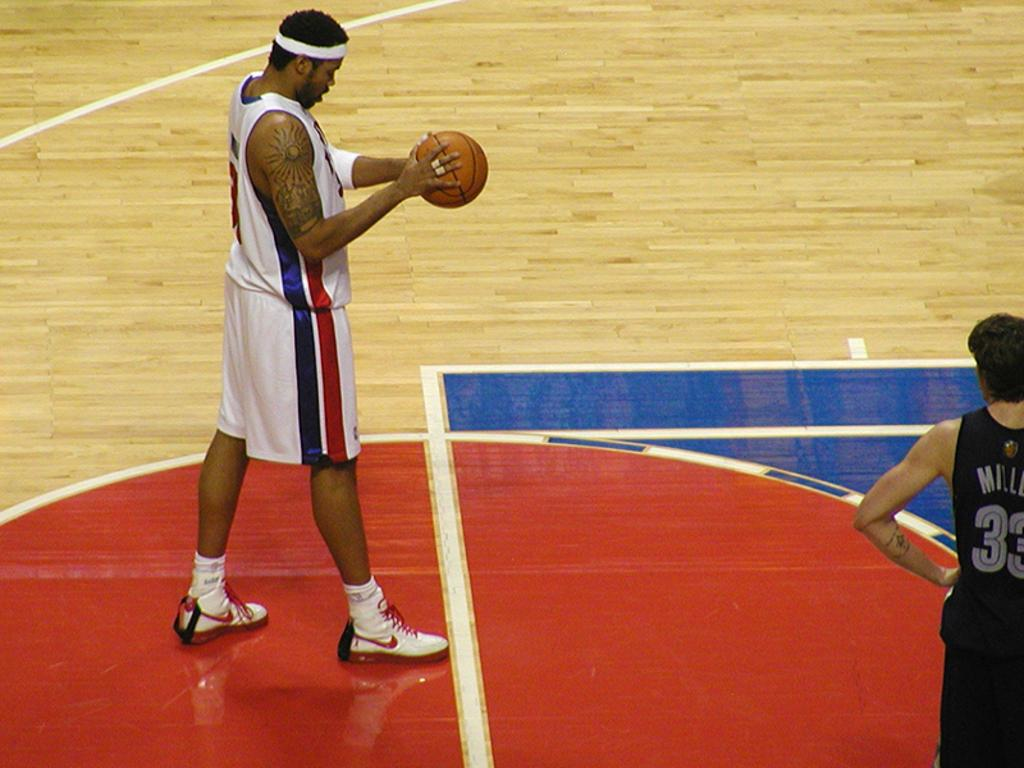What is the person in the image wearing? The person is wearing a white dress in the image. What is the person holding in the image? The person is holding a volleyball in the image. Can you describe the other person in the image? There is another person standing in the right corner of the image. What type of songs can be heard playing in the background of the image? There is no indication of any songs playing in the background of the image. 